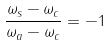Convert formula to latex. <formula><loc_0><loc_0><loc_500><loc_500>\frac { \omega _ { s } - \omega _ { c } } { \omega _ { a } - \omega _ { c } } = - 1</formula> 